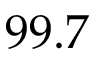<formula> <loc_0><loc_0><loc_500><loc_500>9 9 . 7</formula> 